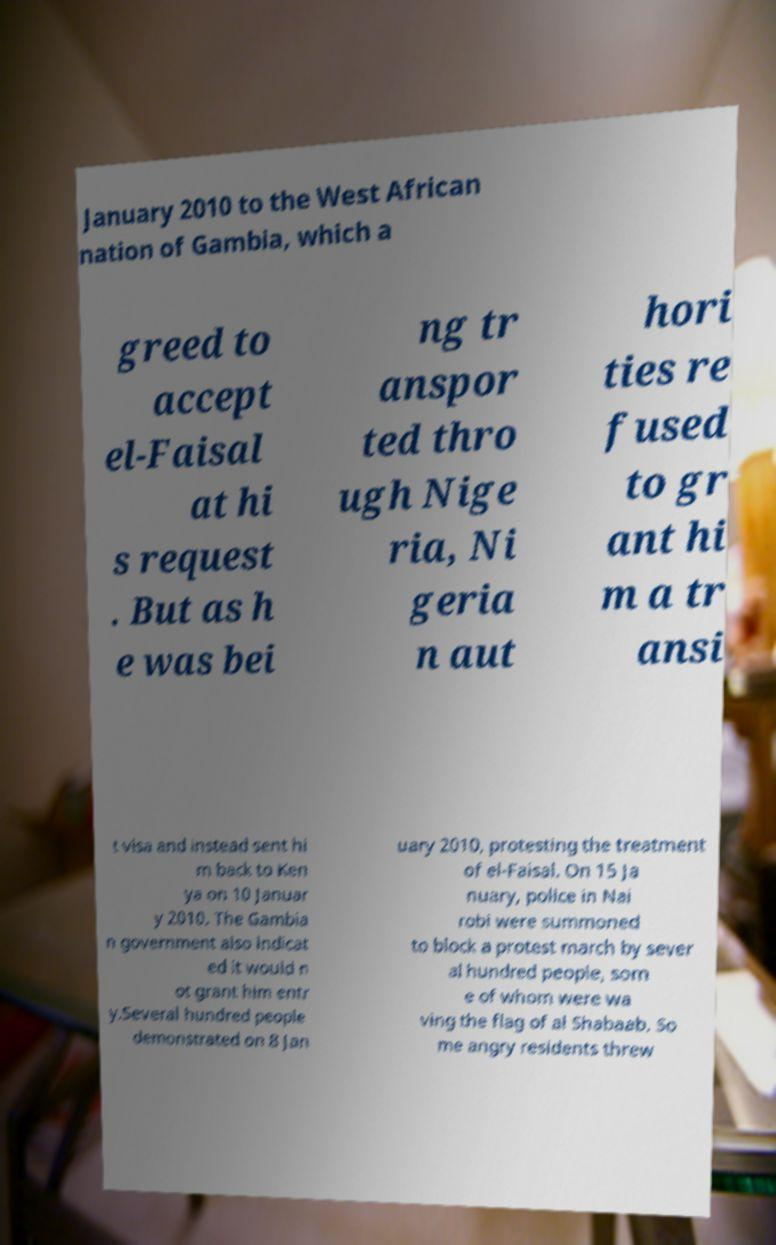Can you accurately transcribe the text from the provided image for me? January 2010 to the West African nation of Gambia, which a greed to accept el-Faisal at hi s request . But as h e was bei ng tr anspor ted thro ugh Nige ria, Ni geria n aut hori ties re fused to gr ant hi m a tr ansi t visa and instead sent hi m back to Ken ya on 10 Januar y 2010. The Gambia n government also indicat ed it would n ot grant him entr y.Several hundred people demonstrated on 8 Jan uary 2010, protesting the treatment of el-Faisal. On 15 Ja nuary, police in Nai robi were summoned to block a protest march by sever al hundred people, som e of whom were wa ving the flag of al Shabaab. So me angry residents threw 